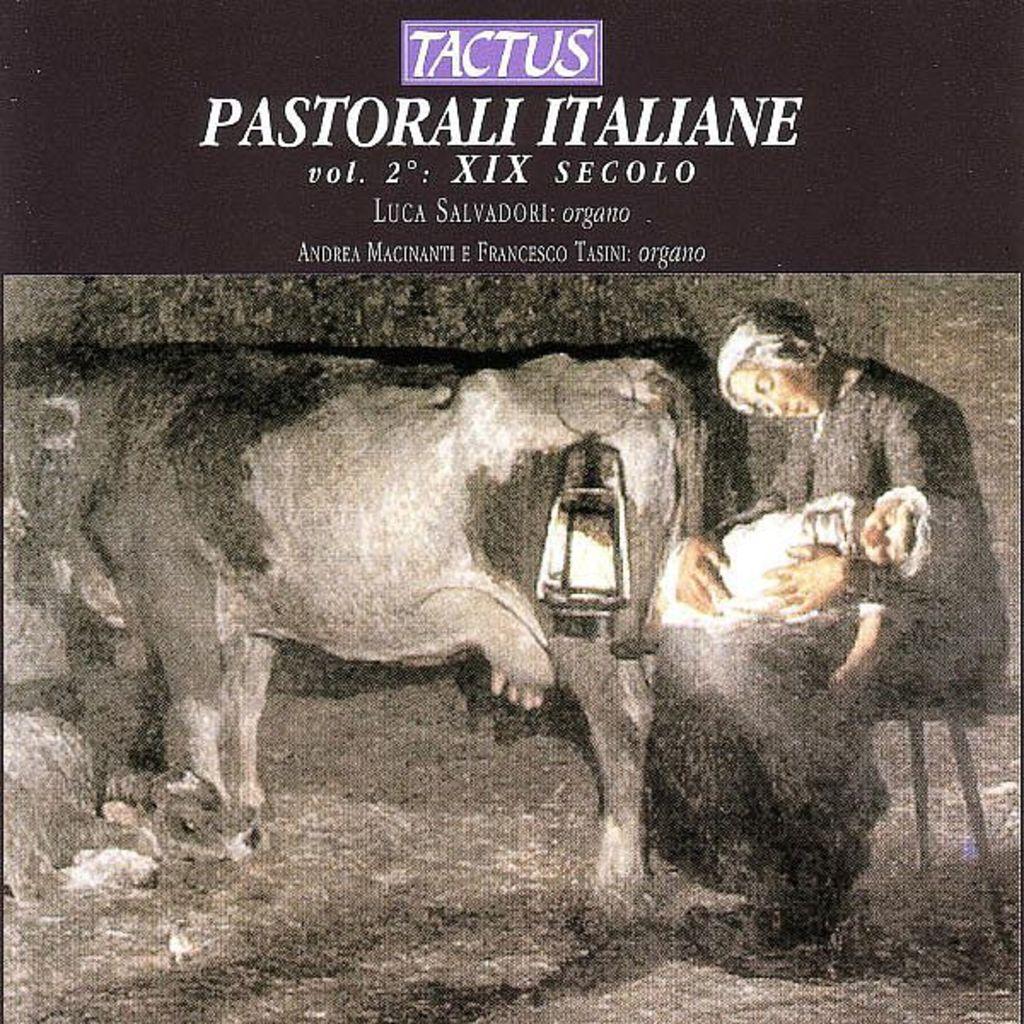Could you give a brief overview of what you see in this image? In this image we can see a poster with text and an image of a woman holding a baby and there is a lamp and a cow. 